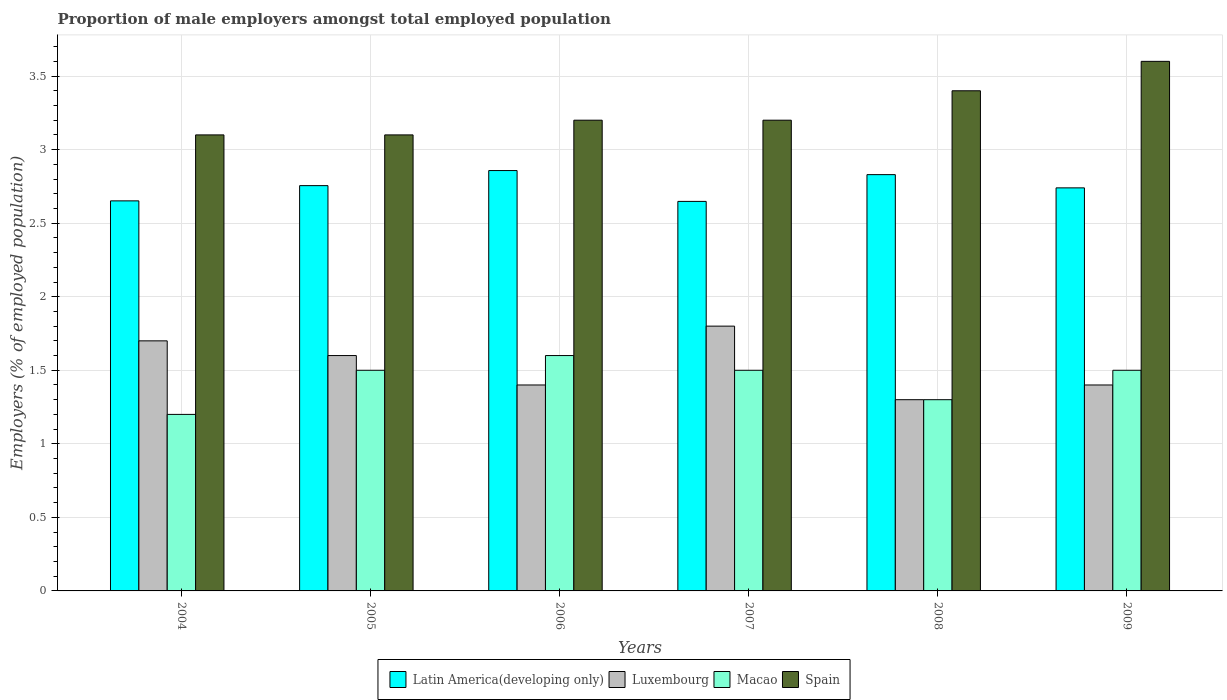Are the number of bars per tick equal to the number of legend labels?
Your response must be concise. Yes. In how many cases, is the number of bars for a given year not equal to the number of legend labels?
Provide a succinct answer. 0. What is the proportion of male employers in Spain in 2005?
Your answer should be compact. 3.1. Across all years, what is the maximum proportion of male employers in Spain?
Keep it short and to the point. 3.6. Across all years, what is the minimum proportion of male employers in Spain?
Your answer should be compact. 3.1. What is the total proportion of male employers in Spain in the graph?
Your answer should be compact. 19.6. What is the difference between the proportion of male employers in Latin America(developing only) in 2005 and the proportion of male employers in Spain in 2006?
Offer a very short reply. -0.44. What is the average proportion of male employers in Macao per year?
Provide a succinct answer. 1.43. In the year 2005, what is the difference between the proportion of male employers in Luxembourg and proportion of male employers in Macao?
Your answer should be very brief. 0.1. In how many years, is the proportion of male employers in Spain greater than 1 %?
Offer a terse response. 6. What is the ratio of the proportion of male employers in Luxembourg in 2007 to that in 2009?
Give a very brief answer. 1.29. What is the difference between the highest and the second highest proportion of male employers in Spain?
Provide a short and direct response. 0.2. What is the difference between the highest and the lowest proportion of male employers in Spain?
Your answer should be compact. 0.5. What does the 1st bar from the left in 2004 represents?
Make the answer very short. Latin America(developing only). What does the 3rd bar from the right in 2004 represents?
Make the answer very short. Luxembourg. How many bars are there?
Your answer should be very brief. 24. Are all the bars in the graph horizontal?
Provide a succinct answer. No. Are the values on the major ticks of Y-axis written in scientific E-notation?
Your response must be concise. No. Does the graph contain any zero values?
Provide a short and direct response. No. Does the graph contain grids?
Your answer should be compact. Yes. What is the title of the graph?
Ensure brevity in your answer.  Proportion of male employers amongst total employed population. Does "Denmark" appear as one of the legend labels in the graph?
Ensure brevity in your answer.  No. What is the label or title of the Y-axis?
Offer a terse response. Employers (% of employed population). What is the Employers (% of employed population) in Latin America(developing only) in 2004?
Your answer should be compact. 2.65. What is the Employers (% of employed population) of Luxembourg in 2004?
Make the answer very short. 1.7. What is the Employers (% of employed population) in Macao in 2004?
Your answer should be compact. 1.2. What is the Employers (% of employed population) in Spain in 2004?
Provide a succinct answer. 3.1. What is the Employers (% of employed population) in Latin America(developing only) in 2005?
Ensure brevity in your answer.  2.76. What is the Employers (% of employed population) in Luxembourg in 2005?
Keep it short and to the point. 1.6. What is the Employers (% of employed population) in Spain in 2005?
Provide a succinct answer. 3.1. What is the Employers (% of employed population) of Latin America(developing only) in 2006?
Your answer should be very brief. 2.86. What is the Employers (% of employed population) in Luxembourg in 2006?
Offer a very short reply. 1.4. What is the Employers (% of employed population) in Macao in 2006?
Give a very brief answer. 1.6. What is the Employers (% of employed population) of Spain in 2006?
Give a very brief answer. 3.2. What is the Employers (% of employed population) in Latin America(developing only) in 2007?
Your answer should be compact. 2.65. What is the Employers (% of employed population) in Luxembourg in 2007?
Offer a terse response. 1.8. What is the Employers (% of employed population) of Spain in 2007?
Provide a succinct answer. 3.2. What is the Employers (% of employed population) of Latin America(developing only) in 2008?
Your answer should be compact. 2.83. What is the Employers (% of employed population) in Luxembourg in 2008?
Ensure brevity in your answer.  1.3. What is the Employers (% of employed population) of Macao in 2008?
Offer a terse response. 1.3. What is the Employers (% of employed population) in Spain in 2008?
Offer a very short reply. 3.4. What is the Employers (% of employed population) in Latin America(developing only) in 2009?
Keep it short and to the point. 2.74. What is the Employers (% of employed population) in Luxembourg in 2009?
Your answer should be very brief. 1.4. What is the Employers (% of employed population) in Spain in 2009?
Keep it short and to the point. 3.6. Across all years, what is the maximum Employers (% of employed population) of Latin America(developing only)?
Your answer should be compact. 2.86. Across all years, what is the maximum Employers (% of employed population) of Luxembourg?
Offer a terse response. 1.8. Across all years, what is the maximum Employers (% of employed population) of Macao?
Provide a short and direct response. 1.6. Across all years, what is the maximum Employers (% of employed population) of Spain?
Keep it short and to the point. 3.6. Across all years, what is the minimum Employers (% of employed population) in Latin America(developing only)?
Make the answer very short. 2.65. Across all years, what is the minimum Employers (% of employed population) of Luxembourg?
Ensure brevity in your answer.  1.3. Across all years, what is the minimum Employers (% of employed population) of Macao?
Give a very brief answer. 1.2. Across all years, what is the minimum Employers (% of employed population) in Spain?
Provide a succinct answer. 3.1. What is the total Employers (% of employed population) in Latin America(developing only) in the graph?
Offer a very short reply. 16.48. What is the total Employers (% of employed population) of Luxembourg in the graph?
Offer a terse response. 9.2. What is the total Employers (% of employed population) in Spain in the graph?
Your answer should be very brief. 19.6. What is the difference between the Employers (% of employed population) of Latin America(developing only) in 2004 and that in 2005?
Make the answer very short. -0.1. What is the difference between the Employers (% of employed population) in Latin America(developing only) in 2004 and that in 2006?
Your answer should be compact. -0.21. What is the difference between the Employers (% of employed population) of Luxembourg in 2004 and that in 2006?
Your answer should be compact. 0.3. What is the difference between the Employers (% of employed population) of Latin America(developing only) in 2004 and that in 2007?
Ensure brevity in your answer.  0. What is the difference between the Employers (% of employed population) of Luxembourg in 2004 and that in 2007?
Your answer should be compact. -0.1. What is the difference between the Employers (% of employed population) in Latin America(developing only) in 2004 and that in 2008?
Your answer should be very brief. -0.18. What is the difference between the Employers (% of employed population) of Latin America(developing only) in 2004 and that in 2009?
Your response must be concise. -0.09. What is the difference between the Employers (% of employed population) of Macao in 2004 and that in 2009?
Provide a short and direct response. -0.3. What is the difference between the Employers (% of employed population) of Spain in 2004 and that in 2009?
Make the answer very short. -0.5. What is the difference between the Employers (% of employed population) in Latin America(developing only) in 2005 and that in 2006?
Your response must be concise. -0.1. What is the difference between the Employers (% of employed population) in Luxembourg in 2005 and that in 2006?
Your answer should be very brief. 0.2. What is the difference between the Employers (% of employed population) in Macao in 2005 and that in 2006?
Provide a short and direct response. -0.1. What is the difference between the Employers (% of employed population) in Latin America(developing only) in 2005 and that in 2007?
Give a very brief answer. 0.11. What is the difference between the Employers (% of employed population) in Macao in 2005 and that in 2007?
Offer a terse response. 0. What is the difference between the Employers (% of employed population) in Spain in 2005 and that in 2007?
Offer a very short reply. -0.1. What is the difference between the Employers (% of employed population) in Latin America(developing only) in 2005 and that in 2008?
Keep it short and to the point. -0.07. What is the difference between the Employers (% of employed population) of Luxembourg in 2005 and that in 2008?
Provide a short and direct response. 0.3. What is the difference between the Employers (% of employed population) of Macao in 2005 and that in 2008?
Offer a terse response. 0.2. What is the difference between the Employers (% of employed population) in Spain in 2005 and that in 2008?
Offer a very short reply. -0.3. What is the difference between the Employers (% of employed population) of Latin America(developing only) in 2005 and that in 2009?
Ensure brevity in your answer.  0.02. What is the difference between the Employers (% of employed population) in Spain in 2005 and that in 2009?
Make the answer very short. -0.5. What is the difference between the Employers (% of employed population) in Latin America(developing only) in 2006 and that in 2007?
Offer a terse response. 0.21. What is the difference between the Employers (% of employed population) of Luxembourg in 2006 and that in 2007?
Provide a short and direct response. -0.4. What is the difference between the Employers (% of employed population) in Macao in 2006 and that in 2007?
Offer a very short reply. 0.1. What is the difference between the Employers (% of employed population) in Latin America(developing only) in 2006 and that in 2008?
Your answer should be very brief. 0.03. What is the difference between the Employers (% of employed population) in Macao in 2006 and that in 2008?
Your answer should be very brief. 0.3. What is the difference between the Employers (% of employed population) of Latin America(developing only) in 2006 and that in 2009?
Offer a very short reply. 0.12. What is the difference between the Employers (% of employed population) in Luxembourg in 2006 and that in 2009?
Make the answer very short. 0. What is the difference between the Employers (% of employed population) in Macao in 2006 and that in 2009?
Keep it short and to the point. 0.1. What is the difference between the Employers (% of employed population) of Spain in 2006 and that in 2009?
Provide a short and direct response. -0.4. What is the difference between the Employers (% of employed population) in Latin America(developing only) in 2007 and that in 2008?
Offer a terse response. -0.18. What is the difference between the Employers (% of employed population) of Luxembourg in 2007 and that in 2008?
Make the answer very short. 0.5. What is the difference between the Employers (% of employed population) in Spain in 2007 and that in 2008?
Your answer should be very brief. -0.2. What is the difference between the Employers (% of employed population) in Latin America(developing only) in 2007 and that in 2009?
Ensure brevity in your answer.  -0.09. What is the difference between the Employers (% of employed population) in Spain in 2007 and that in 2009?
Offer a very short reply. -0.4. What is the difference between the Employers (% of employed population) in Latin America(developing only) in 2008 and that in 2009?
Keep it short and to the point. 0.09. What is the difference between the Employers (% of employed population) in Macao in 2008 and that in 2009?
Offer a terse response. -0.2. What is the difference between the Employers (% of employed population) in Spain in 2008 and that in 2009?
Your answer should be compact. -0.2. What is the difference between the Employers (% of employed population) in Latin America(developing only) in 2004 and the Employers (% of employed population) in Luxembourg in 2005?
Provide a short and direct response. 1.05. What is the difference between the Employers (% of employed population) of Latin America(developing only) in 2004 and the Employers (% of employed population) of Macao in 2005?
Your response must be concise. 1.15. What is the difference between the Employers (% of employed population) of Latin America(developing only) in 2004 and the Employers (% of employed population) of Spain in 2005?
Offer a very short reply. -0.45. What is the difference between the Employers (% of employed population) of Luxembourg in 2004 and the Employers (% of employed population) of Spain in 2005?
Ensure brevity in your answer.  -1.4. What is the difference between the Employers (% of employed population) in Latin America(developing only) in 2004 and the Employers (% of employed population) in Luxembourg in 2006?
Offer a terse response. 1.25. What is the difference between the Employers (% of employed population) of Latin America(developing only) in 2004 and the Employers (% of employed population) of Macao in 2006?
Give a very brief answer. 1.05. What is the difference between the Employers (% of employed population) in Latin America(developing only) in 2004 and the Employers (% of employed population) in Spain in 2006?
Your answer should be very brief. -0.55. What is the difference between the Employers (% of employed population) of Luxembourg in 2004 and the Employers (% of employed population) of Macao in 2006?
Your answer should be compact. 0.1. What is the difference between the Employers (% of employed population) in Luxembourg in 2004 and the Employers (% of employed population) in Spain in 2006?
Provide a succinct answer. -1.5. What is the difference between the Employers (% of employed population) of Macao in 2004 and the Employers (% of employed population) of Spain in 2006?
Offer a terse response. -2. What is the difference between the Employers (% of employed population) in Latin America(developing only) in 2004 and the Employers (% of employed population) in Luxembourg in 2007?
Provide a succinct answer. 0.85. What is the difference between the Employers (% of employed population) of Latin America(developing only) in 2004 and the Employers (% of employed population) of Macao in 2007?
Provide a short and direct response. 1.15. What is the difference between the Employers (% of employed population) in Latin America(developing only) in 2004 and the Employers (% of employed population) in Spain in 2007?
Your answer should be very brief. -0.55. What is the difference between the Employers (% of employed population) in Luxembourg in 2004 and the Employers (% of employed population) in Spain in 2007?
Make the answer very short. -1.5. What is the difference between the Employers (% of employed population) of Macao in 2004 and the Employers (% of employed population) of Spain in 2007?
Offer a very short reply. -2. What is the difference between the Employers (% of employed population) of Latin America(developing only) in 2004 and the Employers (% of employed population) of Luxembourg in 2008?
Offer a very short reply. 1.35. What is the difference between the Employers (% of employed population) of Latin America(developing only) in 2004 and the Employers (% of employed population) of Macao in 2008?
Ensure brevity in your answer.  1.35. What is the difference between the Employers (% of employed population) in Latin America(developing only) in 2004 and the Employers (% of employed population) in Spain in 2008?
Provide a succinct answer. -0.75. What is the difference between the Employers (% of employed population) of Macao in 2004 and the Employers (% of employed population) of Spain in 2008?
Give a very brief answer. -2.2. What is the difference between the Employers (% of employed population) of Latin America(developing only) in 2004 and the Employers (% of employed population) of Luxembourg in 2009?
Make the answer very short. 1.25. What is the difference between the Employers (% of employed population) in Latin America(developing only) in 2004 and the Employers (% of employed population) in Macao in 2009?
Provide a succinct answer. 1.15. What is the difference between the Employers (% of employed population) in Latin America(developing only) in 2004 and the Employers (% of employed population) in Spain in 2009?
Offer a very short reply. -0.95. What is the difference between the Employers (% of employed population) of Macao in 2004 and the Employers (% of employed population) of Spain in 2009?
Offer a very short reply. -2.4. What is the difference between the Employers (% of employed population) of Latin America(developing only) in 2005 and the Employers (% of employed population) of Luxembourg in 2006?
Your answer should be compact. 1.36. What is the difference between the Employers (% of employed population) in Latin America(developing only) in 2005 and the Employers (% of employed population) in Macao in 2006?
Your answer should be very brief. 1.16. What is the difference between the Employers (% of employed population) in Latin America(developing only) in 2005 and the Employers (% of employed population) in Spain in 2006?
Your response must be concise. -0.44. What is the difference between the Employers (% of employed population) of Luxembourg in 2005 and the Employers (% of employed population) of Macao in 2006?
Your response must be concise. 0. What is the difference between the Employers (% of employed population) in Luxembourg in 2005 and the Employers (% of employed population) in Spain in 2006?
Ensure brevity in your answer.  -1.6. What is the difference between the Employers (% of employed population) in Latin America(developing only) in 2005 and the Employers (% of employed population) in Luxembourg in 2007?
Make the answer very short. 0.96. What is the difference between the Employers (% of employed population) in Latin America(developing only) in 2005 and the Employers (% of employed population) in Macao in 2007?
Ensure brevity in your answer.  1.26. What is the difference between the Employers (% of employed population) of Latin America(developing only) in 2005 and the Employers (% of employed population) of Spain in 2007?
Your answer should be compact. -0.44. What is the difference between the Employers (% of employed population) in Latin America(developing only) in 2005 and the Employers (% of employed population) in Luxembourg in 2008?
Provide a short and direct response. 1.46. What is the difference between the Employers (% of employed population) in Latin America(developing only) in 2005 and the Employers (% of employed population) in Macao in 2008?
Provide a succinct answer. 1.46. What is the difference between the Employers (% of employed population) in Latin America(developing only) in 2005 and the Employers (% of employed population) in Spain in 2008?
Give a very brief answer. -0.64. What is the difference between the Employers (% of employed population) of Latin America(developing only) in 2005 and the Employers (% of employed population) of Luxembourg in 2009?
Give a very brief answer. 1.36. What is the difference between the Employers (% of employed population) in Latin America(developing only) in 2005 and the Employers (% of employed population) in Macao in 2009?
Provide a succinct answer. 1.26. What is the difference between the Employers (% of employed population) in Latin America(developing only) in 2005 and the Employers (% of employed population) in Spain in 2009?
Offer a very short reply. -0.84. What is the difference between the Employers (% of employed population) in Luxembourg in 2005 and the Employers (% of employed population) in Spain in 2009?
Provide a succinct answer. -2. What is the difference between the Employers (% of employed population) in Latin America(developing only) in 2006 and the Employers (% of employed population) in Luxembourg in 2007?
Make the answer very short. 1.06. What is the difference between the Employers (% of employed population) in Latin America(developing only) in 2006 and the Employers (% of employed population) in Macao in 2007?
Your answer should be very brief. 1.36. What is the difference between the Employers (% of employed population) of Latin America(developing only) in 2006 and the Employers (% of employed population) of Spain in 2007?
Provide a short and direct response. -0.34. What is the difference between the Employers (% of employed population) of Latin America(developing only) in 2006 and the Employers (% of employed population) of Luxembourg in 2008?
Your answer should be compact. 1.56. What is the difference between the Employers (% of employed population) of Latin America(developing only) in 2006 and the Employers (% of employed population) of Macao in 2008?
Ensure brevity in your answer.  1.56. What is the difference between the Employers (% of employed population) of Latin America(developing only) in 2006 and the Employers (% of employed population) of Spain in 2008?
Your answer should be very brief. -0.54. What is the difference between the Employers (% of employed population) in Luxembourg in 2006 and the Employers (% of employed population) in Macao in 2008?
Your response must be concise. 0.1. What is the difference between the Employers (% of employed population) of Macao in 2006 and the Employers (% of employed population) of Spain in 2008?
Give a very brief answer. -1.8. What is the difference between the Employers (% of employed population) of Latin America(developing only) in 2006 and the Employers (% of employed population) of Luxembourg in 2009?
Offer a terse response. 1.46. What is the difference between the Employers (% of employed population) of Latin America(developing only) in 2006 and the Employers (% of employed population) of Macao in 2009?
Your answer should be very brief. 1.36. What is the difference between the Employers (% of employed population) of Latin America(developing only) in 2006 and the Employers (% of employed population) of Spain in 2009?
Ensure brevity in your answer.  -0.74. What is the difference between the Employers (% of employed population) in Luxembourg in 2006 and the Employers (% of employed population) in Spain in 2009?
Give a very brief answer. -2.2. What is the difference between the Employers (% of employed population) of Latin America(developing only) in 2007 and the Employers (% of employed population) of Luxembourg in 2008?
Your answer should be compact. 1.35. What is the difference between the Employers (% of employed population) in Latin America(developing only) in 2007 and the Employers (% of employed population) in Macao in 2008?
Your answer should be compact. 1.35. What is the difference between the Employers (% of employed population) of Latin America(developing only) in 2007 and the Employers (% of employed population) of Spain in 2008?
Provide a short and direct response. -0.75. What is the difference between the Employers (% of employed population) in Luxembourg in 2007 and the Employers (% of employed population) in Macao in 2008?
Your answer should be very brief. 0.5. What is the difference between the Employers (% of employed population) of Luxembourg in 2007 and the Employers (% of employed population) of Spain in 2008?
Offer a terse response. -1.6. What is the difference between the Employers (% of employed population) in Latin America(developing only) in 2007 and the Employers (% of employed population) in Luxembourg in 2009?
Offer a terse response. 1.25. What is the difference between the Employers (% of employed population) in Latin America(developing only) in 2007 and the Employers (% of employed population) in Macao in 2009?
Ensure brevity in your answer.  1.15. What is the difference between the Employers (% of employed population) in Latin America(developing only) in 2007 and the Employers (% of employed population) in Spain in 2009?
Make the answer very short. -0.95. What is the difference between the Employers (% of employed population) in Luxembourg in 2007 and the Employers (% of employed population) in Macao in 2009?
Provide a succinct answer. 0.3. What is the difference between the Employers (% of employed population) of Macao in 2007 and the Employers (% of employed population) of Spain in 2009?
Provide a short and direct response. -2.1. What is the difference between the Employers (% of employed population) in Latin America(developing only) in 2008 and the Employers (% of employed population) in Luxembourg in 2009?
Offer a very short reply. 1.43. What is the difference between the Employers (% of employed population) in Latin America(developing only) in 2008 and the Employers (% of employed population) in Macao in 2009?
Your answer should be very brief. 1.33. What is the difference between the Employers (% of employed population) in Latin America(developing only) in 2008 and the Employers (% of employed population) in Spain in 2009?
Offer a very short reply. -0.77. What is the difference between the Employers (% of employed population) of Macao in 2008 and the Employers (% of employed population) of Spain in 2009?
Provide a succinct answer. -2.3. What is the average Employers (% of employed population) in Latin America(developing only) per year?
Offer a very short reply. 2.75. What is the average Employers (% of employed population) in Luxembourg per year?
Offer a very short reply. 1.53. What is the average Employers (% of employed population) in Macao per year?
Your answer should be very brief. 1.43. What is the average Employers (% of employed population) of Spain per year?
Keep it short and to the point. 3.27. In the year 2004, what is the difference between the Employers (% of employed population) in Latin America(developing only) and Employers (% of employed population) in Luxembourg?
Offer a terse response. 0.95. In the year 2004, what is the difference between the Employers (% of employed population) of Latin America(developing only) and Employers (% of employed population) of Macao?
Provide a succinct answer. 1.45. In the year 2004, what is the difference between the Employers (% of employed population) in Latin America(developing only) and Employers (% of employed population) in Spain?
Give a very brief answer. -0.45. In the year 2005, what is the difference between the Employers (% of employed population) of Latin America(developing only) and Employers (% of employed population) of Luxembourg?
Your response must be concise. 1.16. In the year 2005, what is the difference between the Employers (% of employed population) of Latin America(developing only) and Employers (% of employed population) of Macao?
Ensure brevity in your answer.  1.26. In the year 2005, what is the difference between the Employers (% of employed population) in Latin America(developing only) and Employers (% of employed population) in Spain?
Make the answer very short. -0.34. In the year 2006, what is the difference between the Employers (% of employed population) in Latin America(developing only) and Employers (% of employed population) in Luxembourg?
Provide a short and direct response. 1.46. In the year 2006, what is the difference between the Employers (% of employed population) of Latin America(developing only) and Employers (% of employed population) of Macao?
Keep it short and to the point. 1.26. In the year 2006, what is the difference between the Employers (% of employed population) of Latin America(developing only) and Employers (% of employed population) of Spain?
Keep it short and to the point. -0.34. In the year 2006, what is the difference between the Employers (% of employed population) of Luxembourg and Employers (% of employed population) of Macao?
Ensure brevity in your answer.  -0.2. In the year 2006, what is the difference between the Employers (% of employed population) in Luxembourg and Employers (% of employed population) in Spain?
Your response must be concise. -1.8. In the year 2007, what is the difference between the Employers (% of employed population) of Latin America(developing only) and Employers (% of employed population) of Luxembourg?
Ensure brevity in your answer.  0.85. In the year 2007, what is the difference between the Employers (% of employed population) in Latin America(developing only) and Employers (% of employed population) in Macao?
Make the answer very short. 1.15. In the year 2007, what is the difference between the Employers (% of employed population) of Latin America(developing only) and Employers (% of employed population) of Spain?
Keep it short and to the point. -0.55. In the year 2008, what is the difference between the Employers (% of employed population) of Latin America(developing only) and Employers (% of employed population) of Luxembourg?
Provide a succinct answer. 1.53. In the year 2008, what is the difference between the Employers (% of employed population) of Latin America(developing only) and Employers (% of employed population) of Macao?
Offer a very short reply. 1.53. In the year 2008, what is the difference between the Employers (% of employed population) in Latin America(developing only) and Employers (% of employed population) in Spain?
Your answer should be compact. -0.57. In the year 2008, what is the difference between the Employers (% of employed population) in Luxembourg and Employers (% of employed population) in Macao?
Your response must be concise. 0. In the year 2008, what is the difference between the Employers (% of employed population) of Luxembourg and Employers (% of employed population) of Spain?
Your answer should be compact. -2.1. In the year 2008, what is the difference between the Employers (% of employed population) in Macao and Employers (% of employed population) in Spain?
Offer a very short reply. -2.1. In the year 2009, what is the difference between the Employers (% of employed population) of Latin America(developing only) and Employers (% of employed population) of Luxembourg?
Give a very brief answer. 1.34. In the year 2009, what is the difference between the Employers (% of employed population) in Latin America(developing only) and Employers (% of employed population) in Macao?
Make the answer very short. 1.24. In the year 2009, what is the difference between the Employers (% of employed population) in Latin America(developing only) and Employers (% of employed population) in Spain?
Make the answer very short. -0.86. In the year 2009, what is the difference between the Employers (% of employed population) of Luxembourg and Employers (% of employed population) of Macao?
Give a very brief answer. -0.1. In the year 2009, what is the difference between the Employers (% of employed population) in Luxembourg and Employers (% of employed population) in Spain?
Your answer should be very brief. -2.2. What is the ratio of the Employers (% of employed population) in Latin America(developing only) in 2004 to that in 2005?
Give a very brief answer. 0.96. What is the ratio of the Employers (% of employed population) in Macao in 2004 to that in 2005?
Ensure brevity in your answer.  0.8. What is the ratio of the Employers (% of employed population) in Latin America(developing only) in 2004 to that in 2006?
Keep it short and to the point. 0.93. What is the ratio of the Employers (% of employed population) of Luxembourg in 2004 to that in 2006?
Give a very brief answer. 1.21. What is the ratio of the Employers (% of employed population) of Macao in 2004 to that in 2006?
Ensure brevity in your answer.  0.75. What is the ratio of the Employers (% of employed population) of Spain in 2004 to that in 2006?
Give a very brief answer. 0.97. What is the ratio of the Employers (% of employed population) of Latin America(developing only) in 2004 to that in 2007?
Offer a very short reply. 1. What is the ratio of the Employers (% of employed population) in Luxembourg in 2004 to that in 2007?
Keep it short and to the point. 0.94. What is the ratio of the Employers (% of employed population) of Spain in 2004 to that in 2007?
Offer a terse response. 0.97. What is the ratio of the Employers (% of employed population) in Latin America(developing only) in 2004 to that in 2008?
Keep it short and to the point. 0.94. What is the ratio of the Employers (% of employed population) of Luxembourg in 2004 to that in 2008?
Ensure brevity in your answer.  1.31. What is the ratio of the Employers (% of employed population) of Spain in 2004 to that in 2008?
Your answer should be compact. 0.91. What is the ratio of the Employers (% of employed population) of Latin America(developing only) in 2004 to that in 2009?
Your response must be concise. 0.97. What is the ratio of the Employers (% of employed population) in Luxembourg in 2004 to that in 2009?
Give a very brief answer. 1.21. What is the ratio of the Employers (% of employed population) of Spain in 2004 to that in 2009?
Give a very brief answer. 0.86. What is the ratio of the Employers (% of employed population) of Latin America(developing only) in 2005 to that in 2006?
Keep it short and to the point. 0.96. What is the ratio of the Employers (% of employed population) of Macao in 2005 to that in 2006?
Your answer should be very brief. 0.94. What is the ratio of the Employers (% of employed population) of Spain in 2005 to that in 2006?
Offer a very short reply. 0.97. What is the ratio of the Employers (% of employed population) of Latin America(developing only) in 2005 to that in 2007?
Make the answer very short. 1.04. What is the ratio of the Employers (% of employed population) of Luxembourg in 2005 to that in 2007?
Your response must be concise. 0.89. What is the ratio of the Employers (% of employed population) of Macao in 2005 to that in 2007?
Make the answer very short. 1. What is the ratio of the Employers (% of employed population) of Spain in 2005 to that in 2007?
Provide a short and direct response. 0.97. What is the ratio of the Employers (% of employed population) in Latin America(developing only) in 2005 to that in 2008?
Offer a very short reply. 0.97. What is the ratio of the Employers (% of employed population) of Luxembourg in 2005 to that in 2008?
Provide a short and direct response. 1.23. What is the ratio of the Employers (% of employed population) of Macao in 2005 to that in 2008?
Your answer should be compact. 1.15. What is the ratio of the Employers (% of employed population) in Spain in 2005 to that in 2008?
Provide a succinct answer. 0.91. What is the ratio of the Employers (% of employed population) of Latin America(developing only) in 2005 to that in 2009?
Keep it short and to the point. 1.01. What is the ratio of the Employers (% of employed population) in Luxembourg in 2005 to that in 2009?
Offer a terse response. 1.14. What is the ratio of the Employers (% of employed population) in Spain in 2005 to that in 2009?
Offer a very short reply. 0.86. What is the ratio of the Employers (% of employed population) in Latin America(developing only) in 2006 to that in 2007?
Provide a succinct answer. 1.08. What is the ratio of the Employers (% of employed population) in Macao in 2006 to that in 2007?
Your answer should be compact. 1.07. What is the ratio of the Employers (% of employed population) in Latin America(developing only) in 2006 to that in 2008?
Give a very brief answer. 1.01. What is the ratio of the Employers (% of employed population) of Luxembourg in 2006 to that in 2008?
Offer a very short reply. 1.08. What is the ratio of the Employers (% of employed population) in Macao in 2006 to that in 2008?
Offer a terse response. 1.23. What is the ratio of the Employers (% of employed population) of Latin America(developing only) in 2006 to that in 2009?
Give a very brief answer. 1.04. What is the ratio of the Employers (% of employed population) in Macao in 2006 to that in 2009?
Offer a very short reply. 1.07. What is the ratio of the Employers (% of employed population) in Latin America(developing only) in 2007 to that in 2008?
Keep it short and to the point. 0.94. What is the ratio of the Employers (% of employed population) in Luxembourg in 2007 to that in 2008?
Provide a short and direct response. 1.38. What is the ratio of the Employers (% of employed population) in Macao in 2007 to that in 2008?
Ensure brevity in your answer.  1.15. What is the ratio of the Employers (% of employed population) of Spain in 2007 to that in 2008?
Keep it short and to the point. 0.94. What is the ratio of the Employers (% of employed population) of Latin America(developing only) in 2007 to that in 2009?
Give a very brief answer. 0.97. What is the ratio of the Employers (% of employed population) of Luxembourg in 2007 to that in 2009?
Your answer should be compact. 1.29. What is the ratio of the Employers (% of employed population) in Macao in 2007 to that in 2009?
Ensure brevity in your answer.  1. What is the ratio of the Employers (% of employed population) of Latin America(developing only) in 2008 to that in 2009?
Provide a short and direct response. 1.03. What is the ratio of the Employers (% of employed population) in Macao in 2008 to that in 2009?
Provide a succinct answer. 0.87. What is the ratio of the Employers (% of employed population) in Spain in 2008 to that in 2009?
Your answer should be compact. 0.94. What is the difference between the highest and the second highest Employers (% of employed population) in Latin America(developing only)?
Your answer should be compact. 0.03. What is the difference between the highest and the second highest Employers (% of employed population) in Luxembourg?
Provide a succinct answer. 0.1. What is the difference between the highest and the second highest Employers (% of employed population) in Macao?
Your answer should be very brief. 0.1. What is the difference between the highest and the second highest Employers (% of employed population) of Spain?
Your answer should be compact. 0.2. What is the difference between the highest and the lowest Employers (% of employed population) in Latin America(developing only)?
Your response must be concise. 0.21. What is the difference between the highest and the lowest Employers (% of employed population) of Luxembourg?
Your answer should be compact. 0.5. What is the difference between the highest and the lowest Employers (% of employed population) in Macao?
Your answer should be very brief. 0.4. 